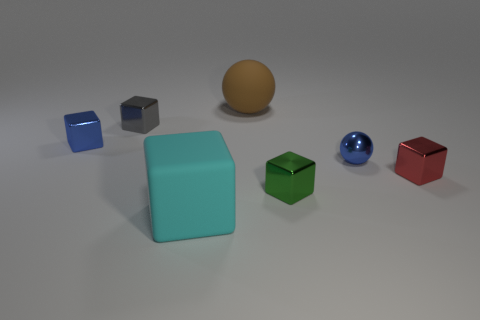Subtract all small blue blocks. How many blocks are left? 4 Add 1 large brown spheres. How many objects exist? 8 Subtract all spheres. How many objects are left? 5 Subtract all gray cubes. How many cubes are left? 4 Subtract 0 purple cylinders. How many objects are left? 7 Subtract 5 cubes. How many cubes are left? 0 Subtract all brown cubes. Subtract all red cylinders. How many cubes are left? 5 Subtract all brown cylinders. How many blue spheres are left? 1 Subtract all tiny green things. Subtract all small gray things. How many objects are left? 5 Add 4 tiny red things. How many tiny red things are left? 5 